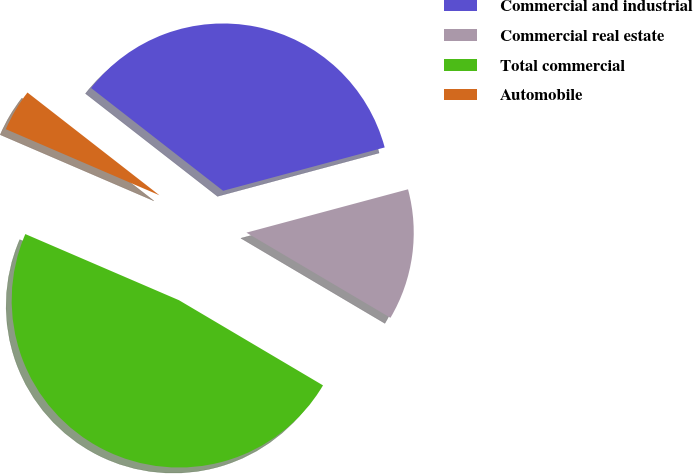<chart> <loc_0><loc_0><loc_500><loc_500><pie_chart><fcel>Commercial and industrial<fcel>Commercial real estate<fcel>Total commercial<fcel>Automobile<nl><fcel>35.3%<fcel>12.67%<fcel>47.97%<fcel>4.06%<nl></chart> 